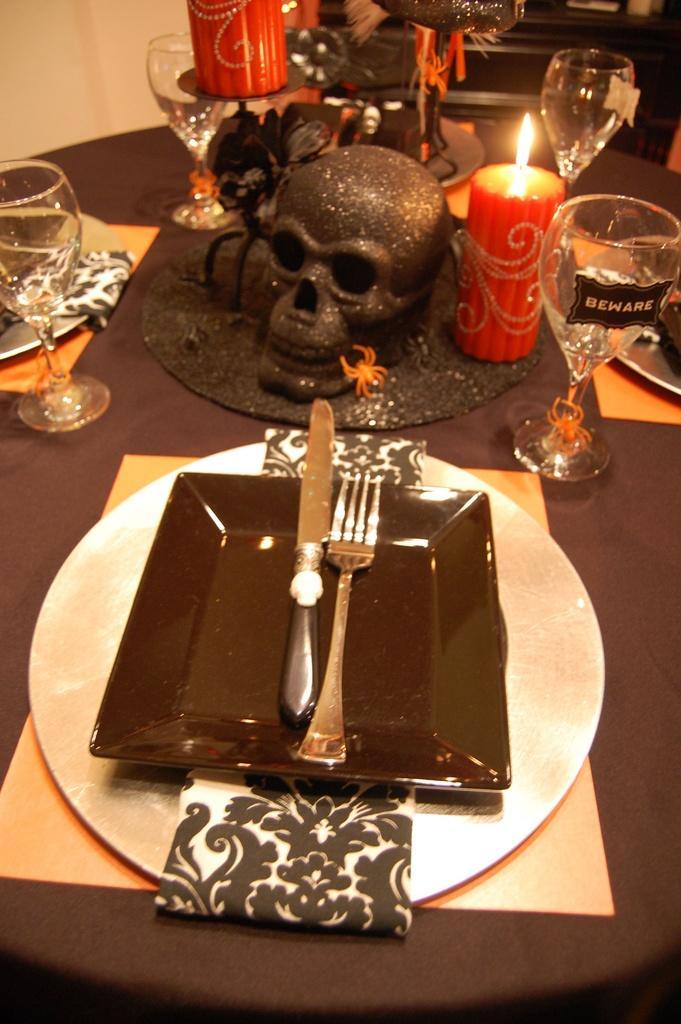Describe this image in one or two sentences. In the image we can see there is a dining table on which there is a plate which is kept upside down and on it there is a knife and fork. In Front of it there is a skull of a human beside its a candle and in front of it there is a wine glass on which its written "BEWARE". 